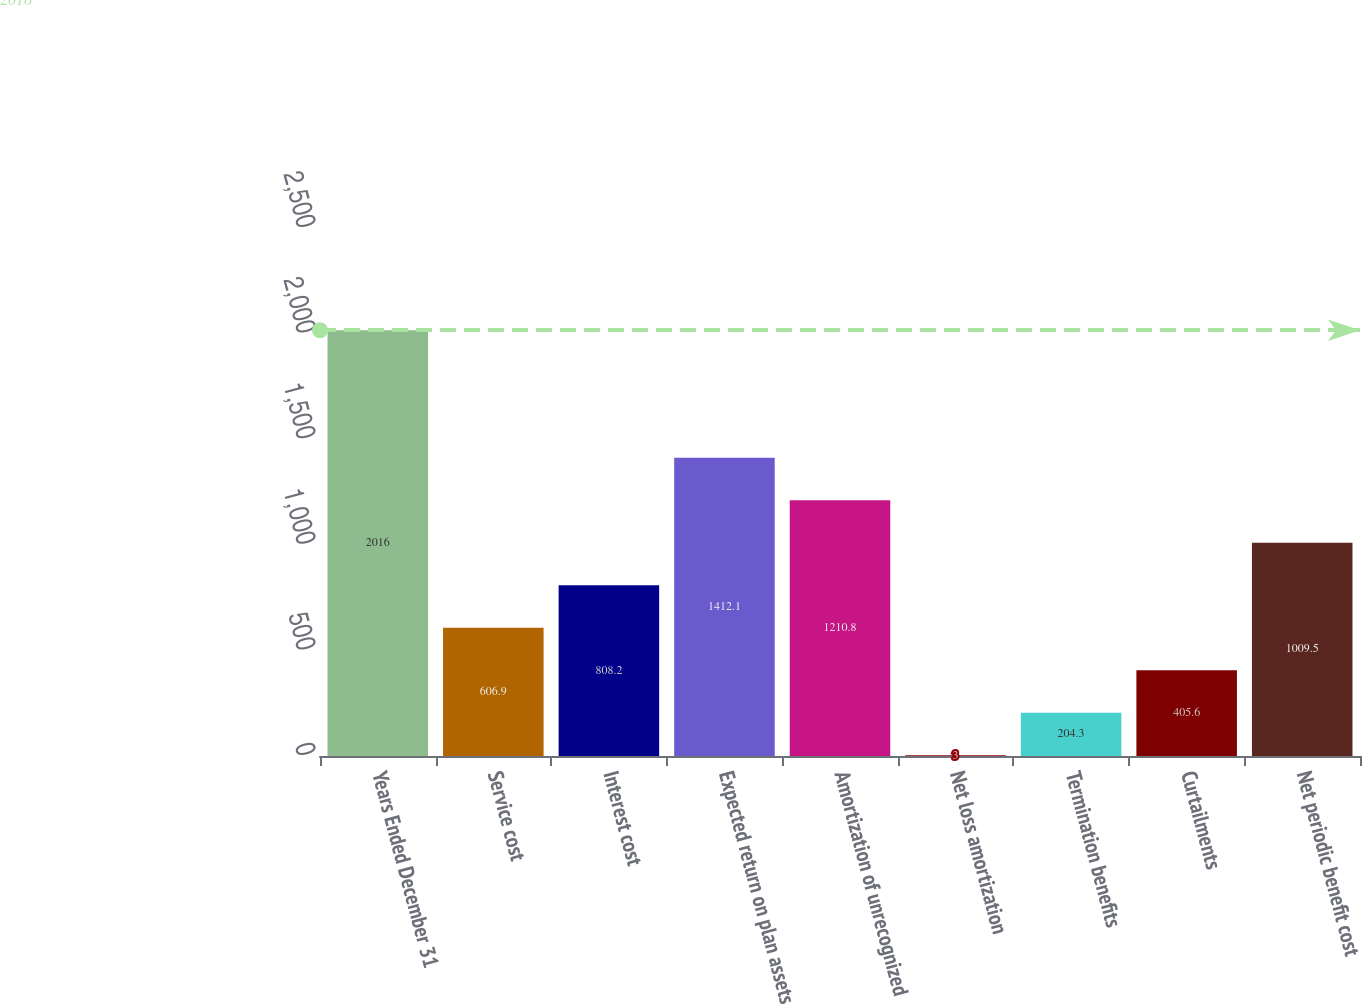<chart> <loc_0><loc_0><loc_500><loc_500><bar_chart><fcel>Years Ended December 31<fcel>Service cost<fcel>Interest cost<fcel>Expected return on plan assets<fcel>Amortization of unrecognized<fcel>Net loss amortization<fcel>Termination benefits<fcel>Curtailments<fcel>Net periodic benefit cost<nl><fcel>2016<fcel>606.9<fcel>808.2<fcel>1412.1<fcel>1210.8<fcel>3<fcel>204.3<fcel>405.6<fcel>1009.5<nl></chart> 